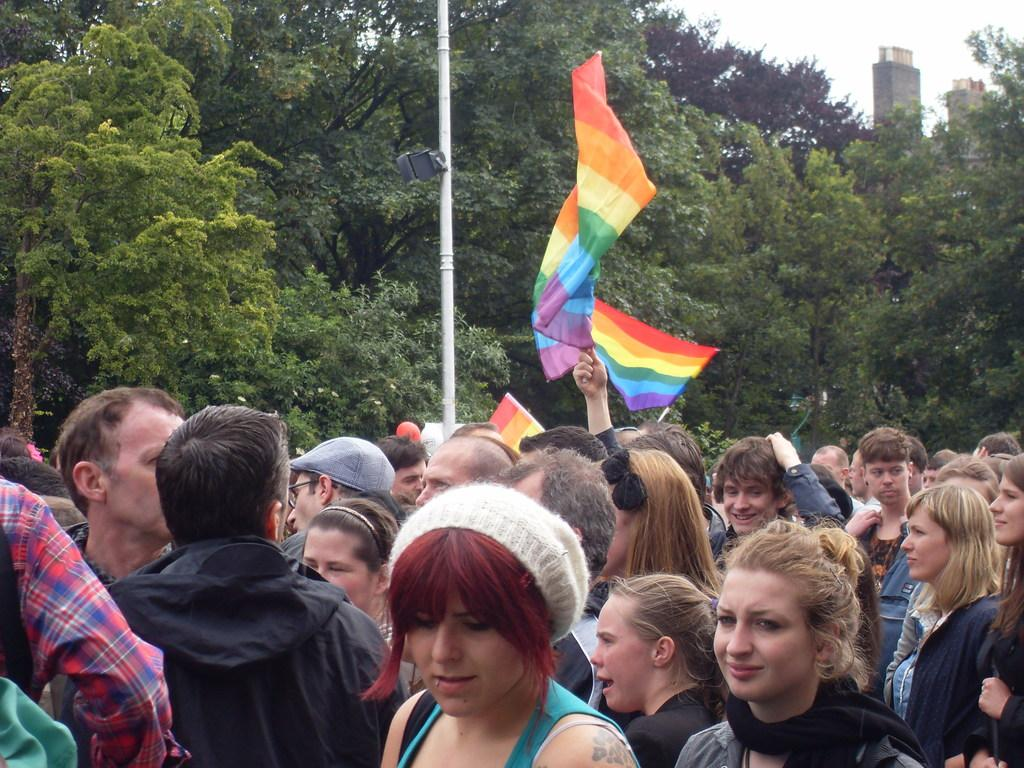Who or what can be seen in the image? There are people in the image. What are some of the people holding? Some of the people are holding flags. Can you describe any other objects or structures in the image? There is a pole in the image. What can be seen in the background of the image? There are trees and buildings in the background of the image. Are there any fairies visible in the image? There are no fairies present in the image. What finger is the person on the left using to hold the flag? The image does not provide enough detail to determine which finger the person on the left is using to hold the flag. 